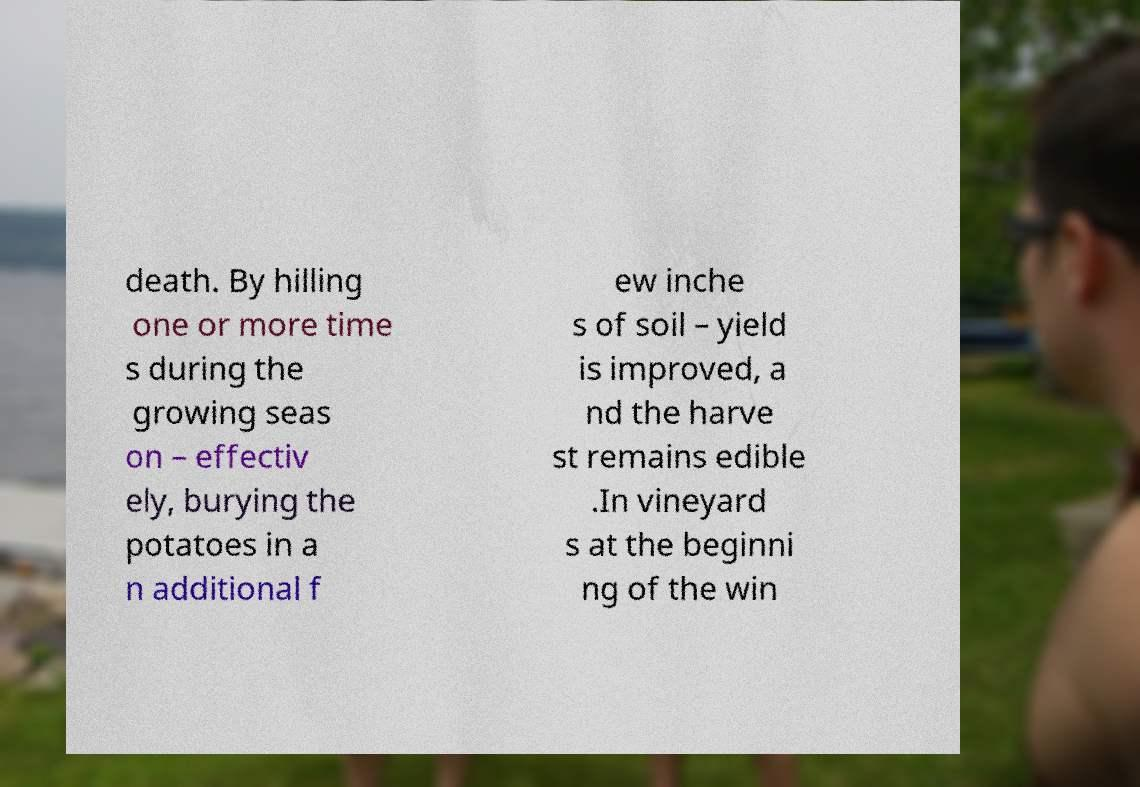There's text embedded in this image that I need extracted. Can you transcribe it verbatim? death. By hilling one or more time s during the growing seas on – effectiv ely, burying the potatoes in a n additional f ew inche s of soil – yield is improved, a nd the harve st remains edible .In vineyard s at the beginni ng of the win 